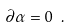<formula> <loc_0><loc_0><loc_500><loc_500>\partial \alpha = 0 \ .</formula> 